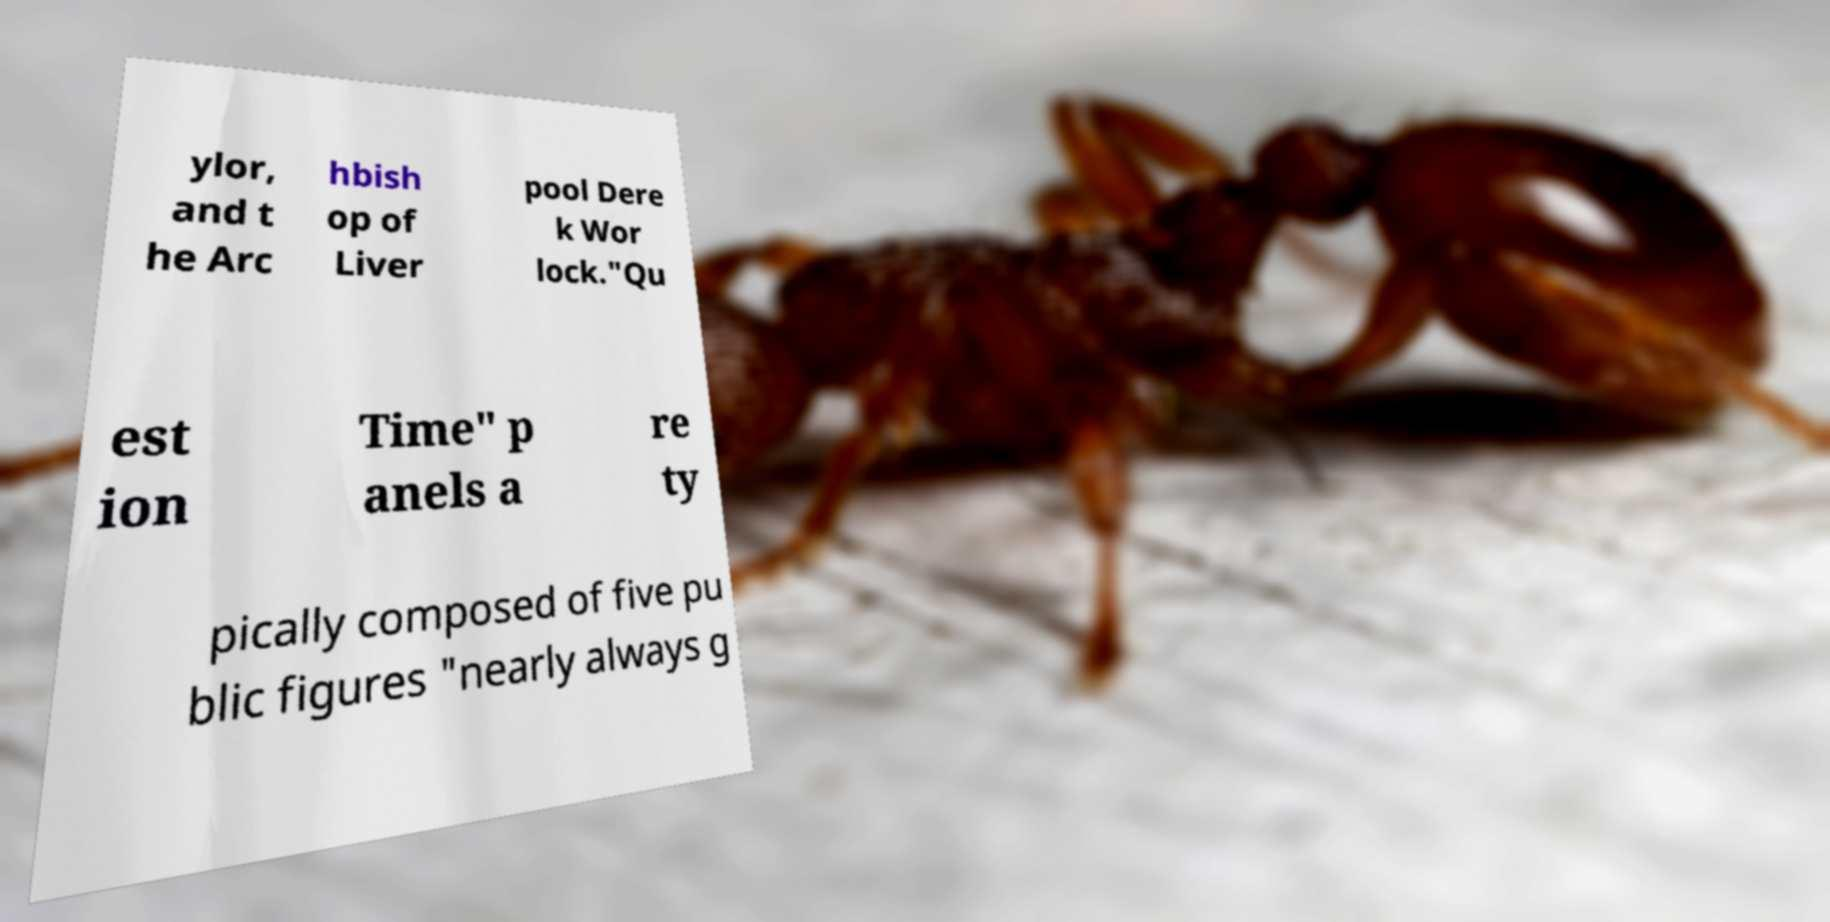Can you read and provide the text displayed in the image?This photo seems to have some interesting text. Can you extract and type it out for me? ylor, and t he Arc hbish op of Liver pool Dere k Wor lock."Qu est ion Time" p anels a re ty pically composed of five pu blic figures "nearly always g 